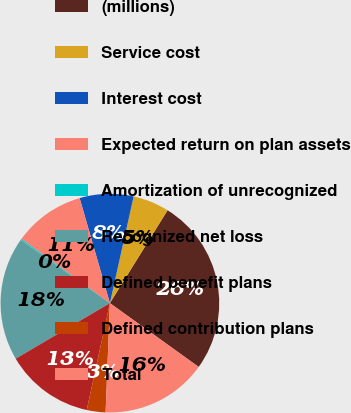Convert chart. <chart><loc_0><loc_0><loc_500><loc_500><pie_chart><fcel>(millions)<fcel>Service cost<fcel>Interest cost<fcel>Expected return on plan assets<fcel>Amortization of unrecognized<fcel>Recognized net loss<fcel>Defined benefit plans<fcel>Defined contribution plans<fcel>Total<nl><fcel>26.07%<fcel>5.36%<fcel>7.95%<fcel>10.54%<fcel>0.18%<fcel>18.3%<fcel>13.12%<fcel>2.77%<fcel>15.71%<nl></chart> 